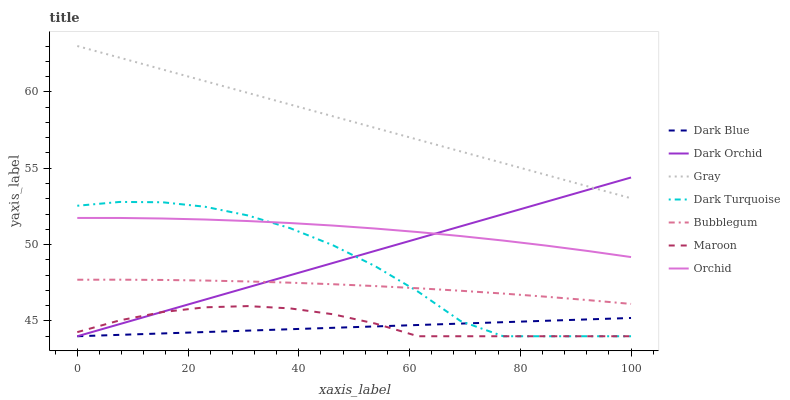Does Dark Turquoise have the minimum area under the curve?
Answer yes or no. No. Does Dark Turquoise have the maximum area under the curve?
Answer yes or no. No. Is Dark Orchid the smoothest?
Answer yes or no. No. Is Dark Orchid the roughest?
Answer yes or no. No. Does Bubblegum have the lowest value?
Answer yes or no. No. Does Dark Turquoise have the highest value?
Answer yes or no. No. Is Dark Blue less than Gray?
Answer yes or no. Yes. Is Gray greater than Bubblegum?
Answer yes or no. Yes. Does Dark Blue intersect Gray?
Answer yes or no. No. 